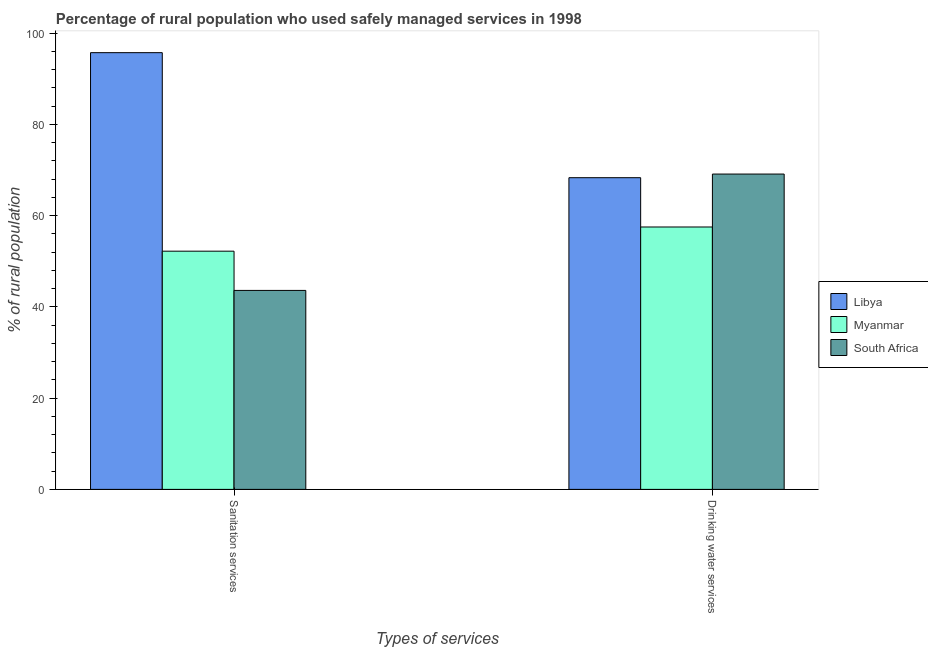How many different coloured bars are there?
Keep it short and to the point. 3. Are the number of bars on each tick of the X-axis equal?
Keep it short and to the point. Yes. How many bars are there on the 1st tick from the right?
Give a very brief answer. 3. What is the label of the 1st group of bars from the left?
Ensure brevity in your answer.  Sanitation services. What is the percentage of rural population who used sanitation services in Libya?
Your answer should be compact. 95.7. Across all countries, what is the maximum percentage of rural population who used sanitation services?
Your answer should be very brief. 95.7. Across all countries, what is the minimum percentage of rural population who used sanitation services?
Your answer should be very brief. 43.6. In which country was the percentage of rural population who used drinking water services maximum?
Provide a short and direct response. South Africa. In which country was the percentage of rural population who used drinking water services minimum?
Make the answer very short. Myanmar. What is the total percentage of rural population who used drinking water services in the graph?
Provide a short and direct response. 194.9. What is the difference between the percentage of rural population who used sanitation services in South Africa and that in Myanmar?
Provide a short and direct response. -8.6. What is the difference between the percentage of rural population who used drinking water services in Myanmar and the percentage of rural population who used sanitation services in South Africa?
Provide a short and direct response. 13.9. What is the average percentage of rural population who used sanitation services per country?
Your response must be concise. 63.83. What is the difference between the percentage of rural population who used sanitation services and percentage of rural population who used drinking water services in Myanmar?
Provide a succinct answer. -5.3. In how many countries, is the percentage of rural population who used sanitation services greater than 52 %?
Your response must be concise. 2. What is the ratio of the percentage of rural population who used sanitation services in Libya to that in Myanmar?
Offer a terse response. 1.83. In how many countries, is the percentage of rural population who used drinking water services greater than the average percentage of rural population who used drinking water services taken over all countries?
Your response must be concise. 2. What does the 3rd bar from the left in Drinking water services represents?
Provide a succinct answer. South Africa. What does the 1st bar from the right in Sanitation services represents?
Your answer should be compact. South Africa. How many bars are there?
Offer a very short reply. 6. Are all the bars in the graph horizontal?
Your response must be concise. No. Are the values on the major ticks of Y-axis written in scientific E-notation?
Your answer should be very brief. No. Does the graph contain grids?
Offer a terse response. No. Where does the legend appear in the graph?
Ensure brevity in your answer.  Center right. How many legend labels are there?
Ensure brevity in your answer.  3. What is the title of the graph?
Make the answer very short. Percentage of rural population who used safely managed services in 1998. What is the label or title of the X-axis?
Keep it short and to the point. Types of services. What is the label or title of the Y-axis?
Ensure brevity in your answer.  % of rural population. What is the % of rural population in Libya in Sanitation services?
Make the answer very short. 95.7. What is the % of rural population of Myanmar in Sanitation services?
Offer a very short reply. 52.2. What is the % of rural population of South Africa in Sanitation services?
Keep it short and to the point. 43.6. What is the % of rural population in Libya in Drinking water services?
Keep it short and to the point. 68.3. What is the % of rural population of Myanmar in Drinking water services?
Your response must be concise. 57.5. What is the % of rural population in South Africa in Drinking water services?
Offer a very short reply. 69.1. Across all Types of services, what is the maximum % of rural population in Libya?
Offer a terse response. 95.7. Across all Types of services, what is the maximum % of rural population in Myanmar?
Provide a short and direct response. 57.5. Across all Types of services, what is the maximum % of rural population in South Africa?
Ensure brevity in your answer.  69.1. Across all Types of services, what is the minimum % of rural population of Libya?
Give a very brief answer. 68.3. Across all Types of services, what is the minimum % of rural population in Myanmar?
Your answer should be compact. 52.2. Across all Types of services, what is the minimum % of rural population of South Africa?
Offer a terse response. 43.6. What is the total % of rural population of Libya in the graph?
Your response must be concise. 164. What is the total % of rural population in Myanmar in the graph?
Ensure brevity in your answer.  109.7. What is the total % of rural population of South Africa in the graph?
Provide a succinct answer. 112.7. What is the difference between the % of rural population of Libya in Sanitation services and that in Drinking water services?
Your answer should be compact. 27.4. What is the difference between the % of rural population of Myanmar in Sanitation services and that in Drinking water services?
Keep it short and to the point. -5.3. What is the difference between the % of rural population in South Africa in Sanitation services and that in Drinking water services?
Your answer should be very brief. -25.5. What is the difference between the % of rural population of Libya in Sanitation services and the % of rural population of Myanmar in Drinking water services?
Offer a terse response. 38.2. What is the difference between the % of rural population in Libya in Sanitation services and the % of rural population in South Africa in Drinking water services?
Ensure brevity in your answer.  26.6. What is the difference between the % of rural population of Myanmar in Sanitation services and the % of rural population of South Africa in Drinking water services?
Ensure brevity in your answer.  -16.9. What is the average % of rural population in Libya per Types of services?
Make the answer very short. 82. What is the average % of rural population of Myanmar per Types of services?
Your response must be concise. 54.85. What is the average % of rural population of South Africa per Types of services?
Provide a succinct answer. 56.35. What is the difference between the % of rural population of Libya and % of rural population of Myanmar in Sanitation services?
Your response must be concise. 43.5. What is the difference between the % of rural population in Libya and % of rural population in South Africa in Sanitation services?
Your answer should be very brief. 52.1. What is the difference between the % of rural population of Libya and % of rural population of Myanmar in Drinking water services?
Your answer should be compact. 10.8. What is the difference between the % of rural population in Libya and % of rural population in South Africa in Drinking water services?
Provide a short and direct response. -0.8. What is the difference between the % of rural population in Myanmar and % of rural population in South Africa in Drinking water services?
Keep it short and to the point. -11.6. What is the ratio of the % of rural population in Libya in Sanitation services to that in Drinking water services?
Your answer should be very brief. 1.4. What is the ratio of the % of rural population of Myanmar in Sanitation services to that in Drinking water services?
Provide a short and direct response. 0.91. What is the ratio of the % of rural population of South Africa in Sanitation services to that in Drinking water services?
Provide a short and direct response. 0.63. What is the difference between the highest and the second highest % of rural population in Libya?
Offer a very short reply. 27.4. What is the difference between the highest and the second highest % of rural population in Myanmar?
Keep it short and to the point. 5.3. What is the difference between the highest and the lowest % of rural population in Libya?
Offer a very short reply. 27.4. 